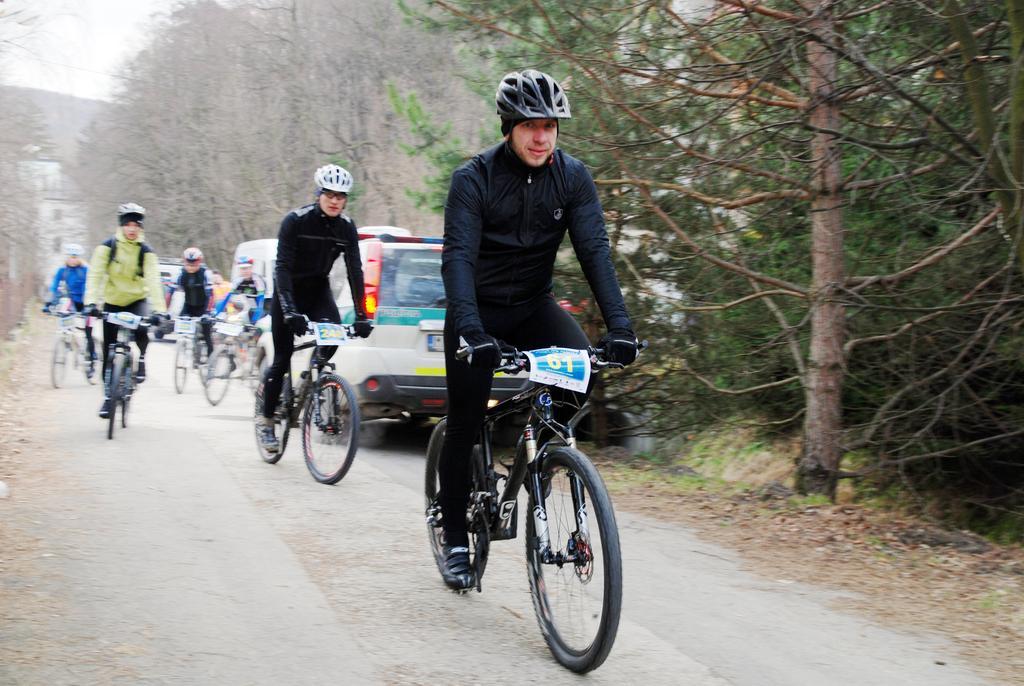Could you give a brief overview of what you see in this image? In this image we can see few persons riding bicycles. Beside the persons we can see the vehicles and a group of trees. In the top left, we can see the sky. 